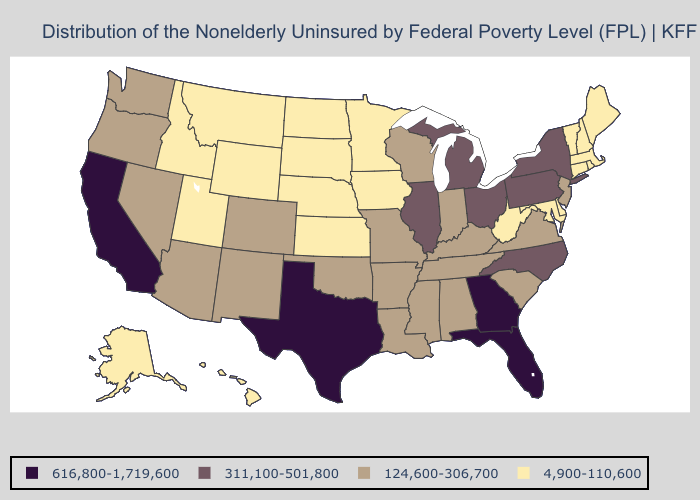Does Louisiana have a higher value than Minnesota?
Quick response, please. Yes. Does the first symbol in the legend represent the smallest category?
Give a very brief answer. No. Does New Hampshire have a higher value than Arizona?
Answer briefly. No. What is the lowest value in states that border South Dakota?
Concise answer only. 4,900-110,600. Does Wyoming have the same value as Idaho?
Answer briefly. Yes. Name the states that have a value in the range 616,800-1,719,600?
Short answer required. California, Florida, Georgia, Texas. Which states have the lowest value in the USA?
Keep it brief. Alaska, Connecticut, Delaware, Hawaii, Idaho, Iowa, Kansas, Maine, Maryland, Massachusetts, Minnesota, Montana, Nebraska, New Hampshire, North Dakota, Rhode Island, South Dakota, Utah, Vermont, West Virginia, Wyoming. What is the value of South Dakota?
Short answer required. 4,900-110,600. Name the states that have a value in the range 616,800-1,719,600?
Give a very brief answer. California, Florida, Georgia, Texas. Does Kentucky have the same value as West Virginia?
Keep it brief. No. What is the highest value in the South ?
Write a very short answer. 616,800-1,719,600. Among the states that border Oregon , which have the lowest value?
Concise answer only. Idaho. What is the value of South Dakota?
Keep it brief. 4,900-110,600. Which states have the highest value in the USA?
Give a very brief answer. California, Florida, Georgia, Texas. Does Massachusetts have the lowest value in the USA?
Be succinct. Yes. 